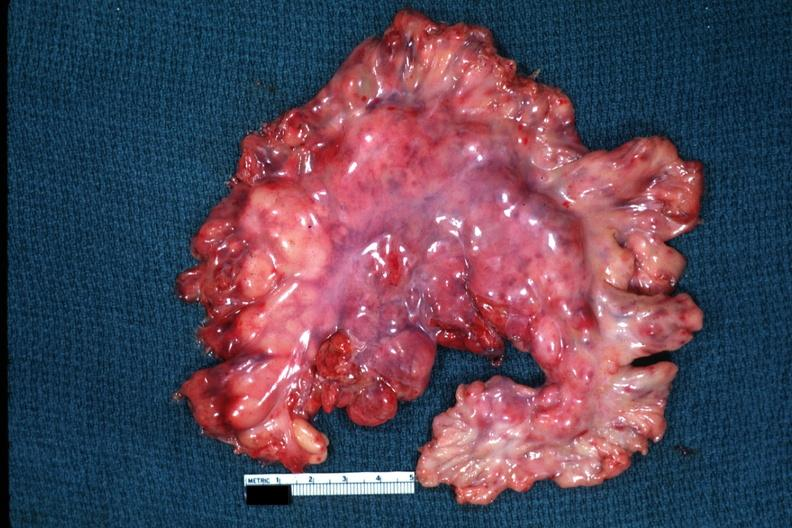where is this area in the body?
Answer the question using a single word or phrase. Abdomen 